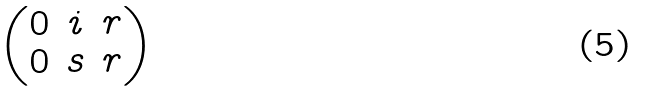Convert formula to latex. <formula><loc_0><loc_0><loc_500><loc_500>\begin{pmatrix} 0 & i & r \\ 0 & s & r \end{pmatrix}</formula> 